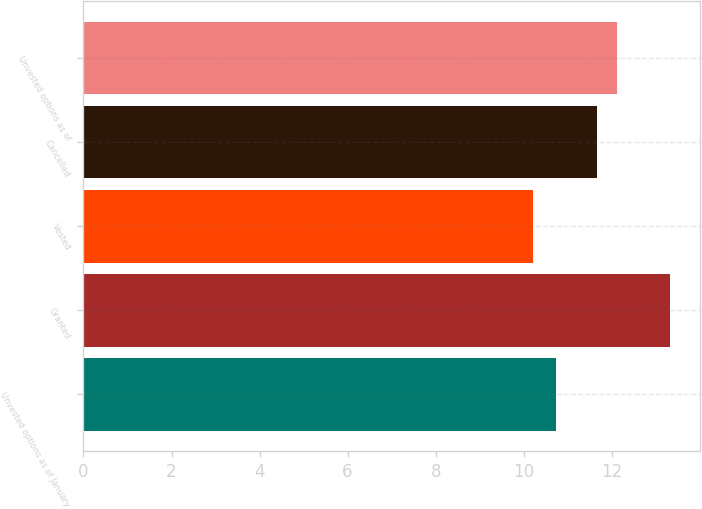Convert chart to OTSL. <chart><loc_0><loc_0><loc_500><loc_500><bar_chart><fcel>Unvested options as of January<fcel>Granted<fcel>Vested<fcel>Cancelled<fcel>Unvested options as of<nl><fcel>10.74<fcel>13.33<fcel>10.22<fcel>11.66<fcel>12.12<nl></chart> 